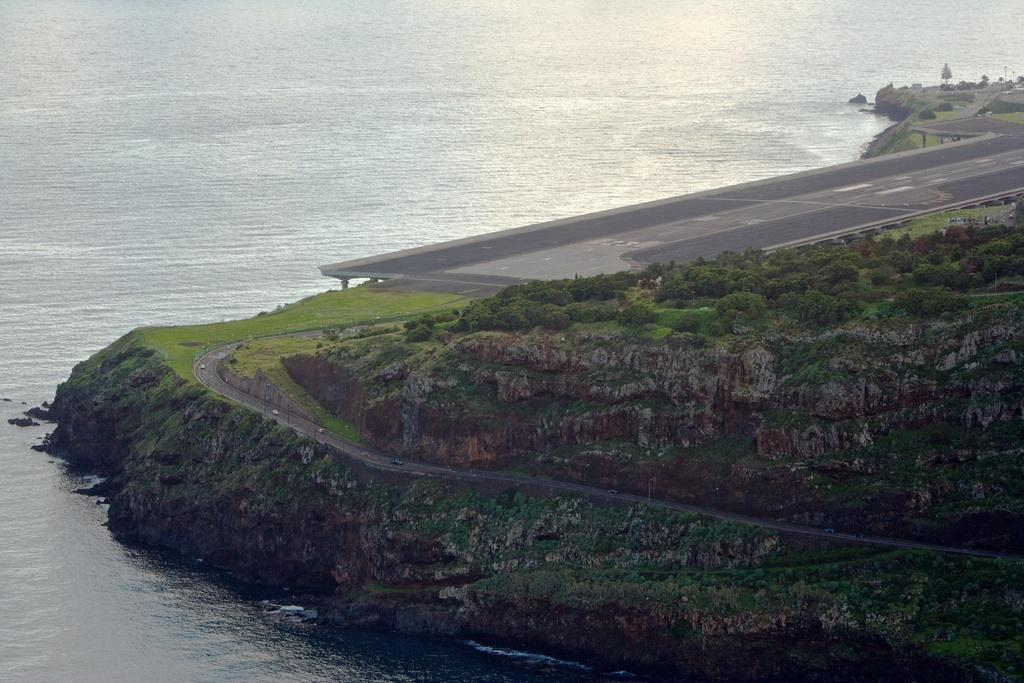What can be seen at the top side of the image? There is water at the top side of the image. What type of vegetation is on the right side of the image? There is greenery on the right side of the image. How many fingers can be seen playing the drum in the image? There is no drum or fingers present in the image. What type of flowers are growing in the greenery on the right side of the image? There is no mention of flowers in the image; only greenery is described. 